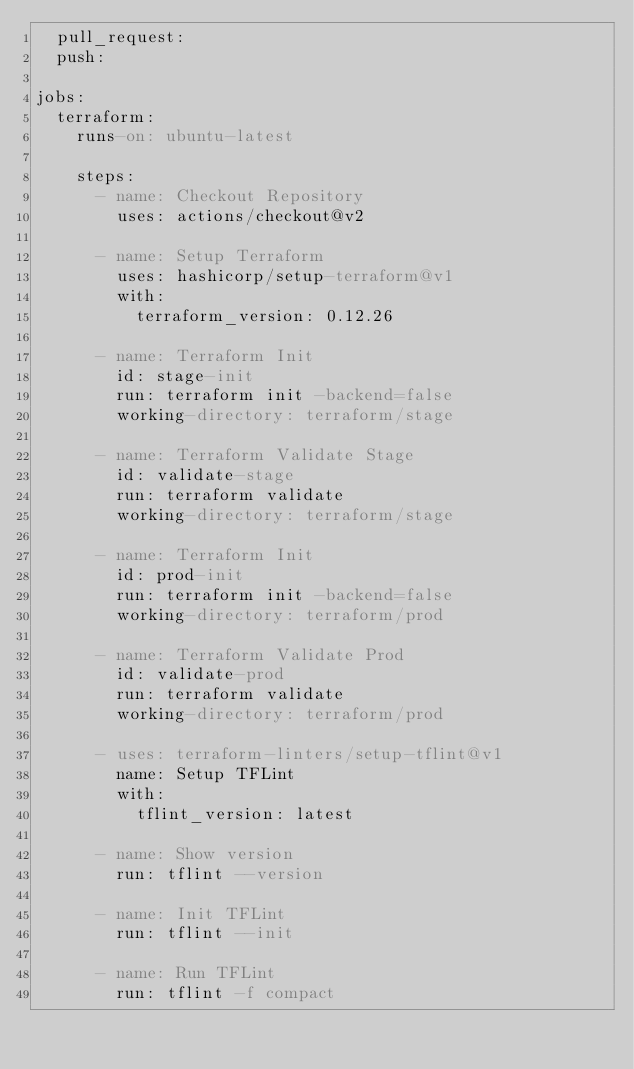Convert code to text. <code><loc_0><loc_0><loc_500><loc_500><_YAML_>  pull_request:
  push:

jobs:
  terraform:
    runs-on: ubuntu-latest

    steps:
      - name: Checkout Repository
        uses: actions/checkout@v2

      - name: Setup Terraform
        uses: hashicorp/setup-terraform@v1
        with:
          terraform_version: 0.12.26

      - name: Terraform Init
        id: stage-init
        run: terraform init -backend=false
        working-directory: terraform/stage

      - name: Terraform Validate Stage
        id: validate-stage
        run: terraform validate
        working-directory: terraform/stage

      - name: Terraform Init
        id: prod-init
        run: terraform init -backend=false
        working-directory: terraform/prod

      - name: Terraform Validate Prod
        id: validate-prod
        run: terraform validate
        working-directory: terraform/prod

      - uses: terraform-linters/setup-tflint@v1
        name: Setup TFLint
        with:
          tflint_version: latest

      - name: Show version
        run: tflint --version

      - name: Init TFLint
        run: tflint --init

      - name: Run TFLint
        run: tflint -f compact
</code> 